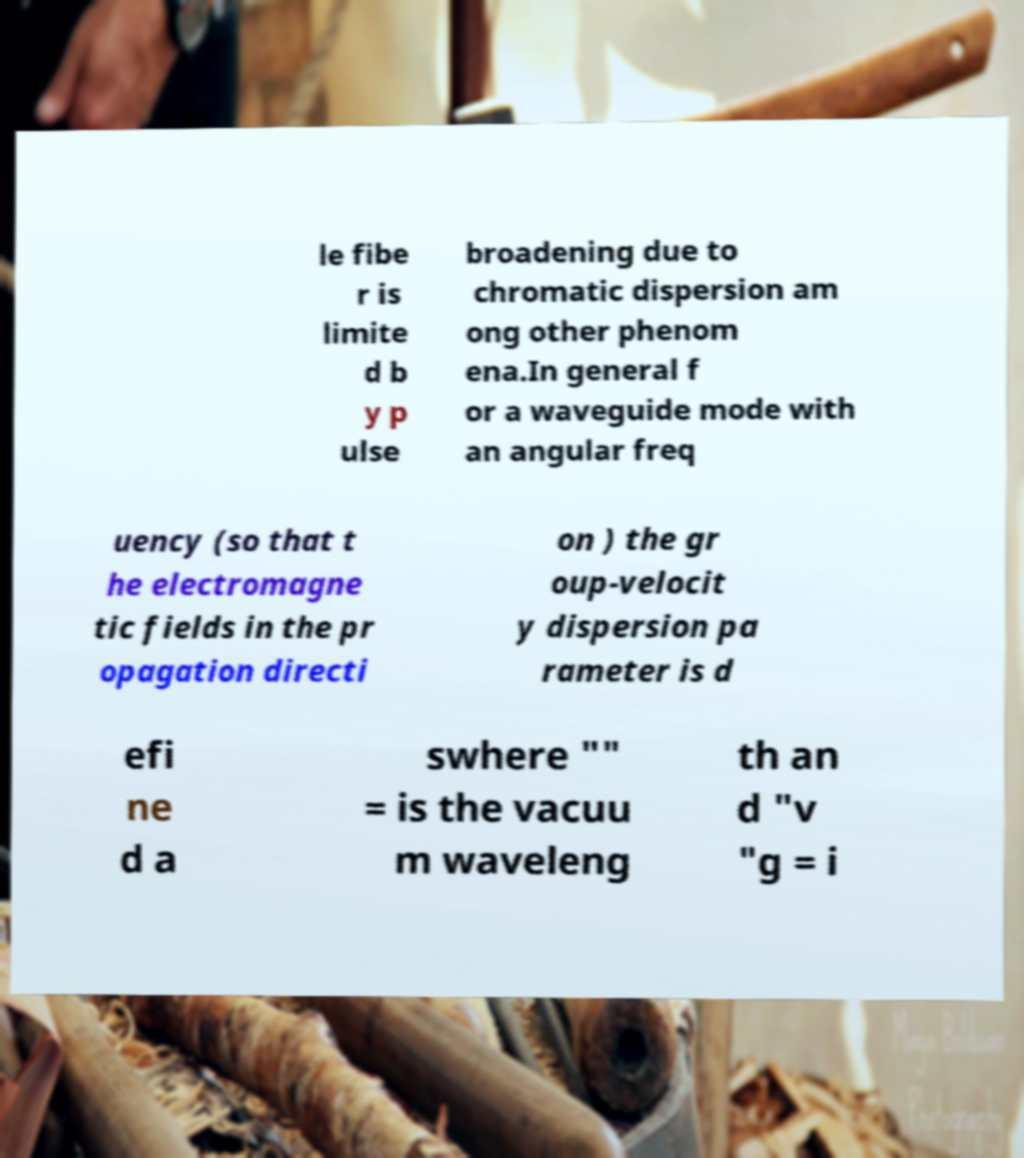Could you extract and type out the text from this image? le fibe r is limite d b y p ulse broadening due to chromatic dispersion am ong other phenom ena.In general f or a waveguide mode with an angular freq uency (so that t he electromagne tic fields in the pr opagation directi on ) the gr oup-velocit y dispersion pa rameter is d efi ne d a swhere "" = is the vacuu m waveleng th an d "v "g = i 